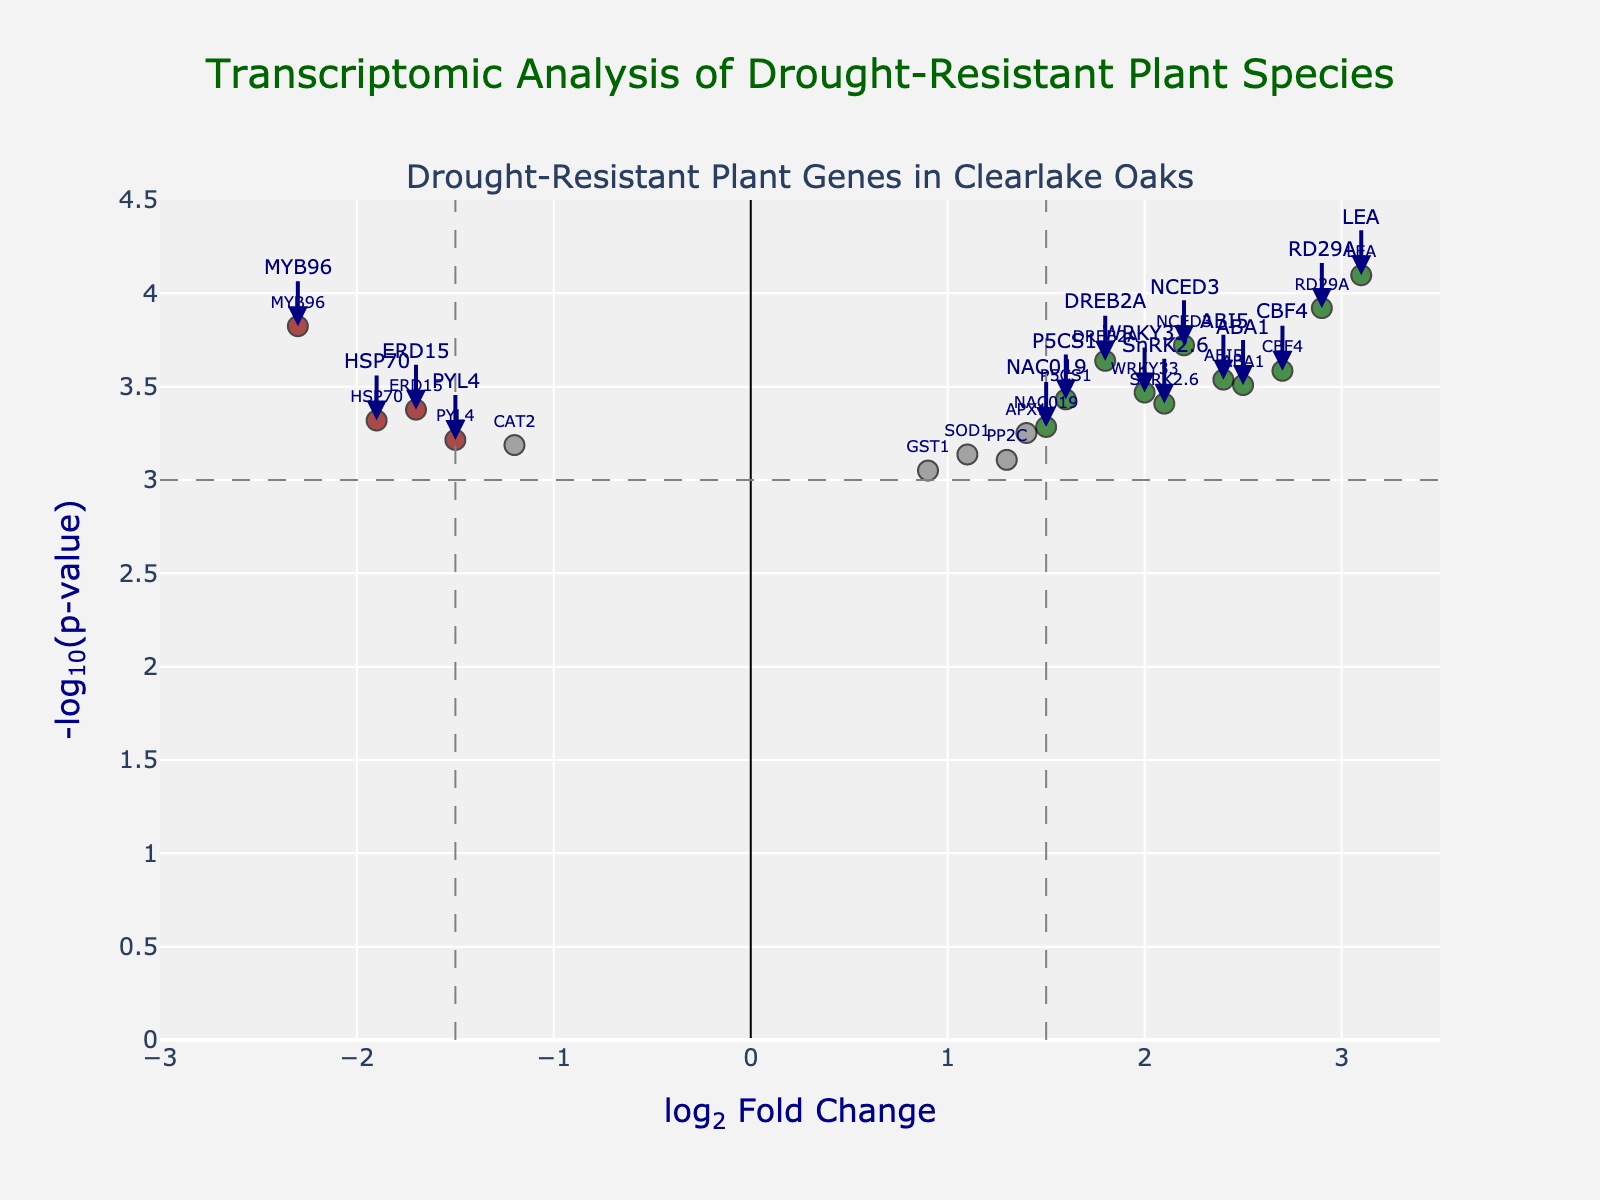How many data points in the plot have a log2 fold change greater than 0? Count all the data points that have a log2 fold change greater than 0.
Answer: 14 What is the title of the Volcano Plot? Read the title from the top of the plot.
Answer: Transcriptomic Analysis of Drought-Resistant Plant Species Which gene has the highest log2 fold change value? Identify the gene with the largest positive log2 fold change value.
Answer: LEA How many genes have a -log10(p-value) greater than 3? Count the data points with a -log10(p-value) value greater than 3.
Answer: 6 Which gene shows the most significant down-regulation? Identify the gene with the smallest log2 fold change, indicating the most significant down-regulation.
Answer: MYB96 Are there more genes with significant up-regulation or down-regulation? Count the number of significantly up-regulated and down-regulated genes, and compare.
Answer: Up-regulation Which gene is closest to the threshold of significant up-regulation and has the smallest p-value among them? Among genes with a log2 fold change greater than 1.5, find the one with the smallest p-value.
Answer: RD29A What color represents genes that are neither significantly up-regulated nor down-regulated? Identify the color used for non-significant genes based on the legend or color key.
Answer: Grey How many genes have both log2 fold change values less than -1.5 and p-values below 0.001? Identify and count the genes that meet both conditions for significant down-regulation.
Answer: 1 Which gene has the lowest p-value among significantly up-regulated genes? Among the genes with a log2 fold change greater than 1.5, identify the one with the smallest p-value.
Answer: LEA 